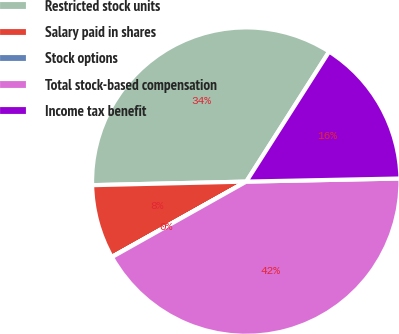Convert chart. <chart><loc_0><loc_0><loc_500><loc_500><pie_chart><fcel>Restricted stock units<fcel>Salary paid in shares<fcel>Stock options<fcel>Total stock-based compensation<fcel>Income tax benefit<nl><fcel>34.4%<fcel>7.76%<fcel>0.02%<fcel>42.17%<fcel>15.65%<nl></chart> 